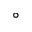<formula> <loc_0><loc_0><loc_500><loc_500>^ { \circ }</formula> 